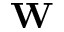Convert formula to latex. <formula><loc_0><loc_0><loc_500><loc_500>{ W }</formula> 